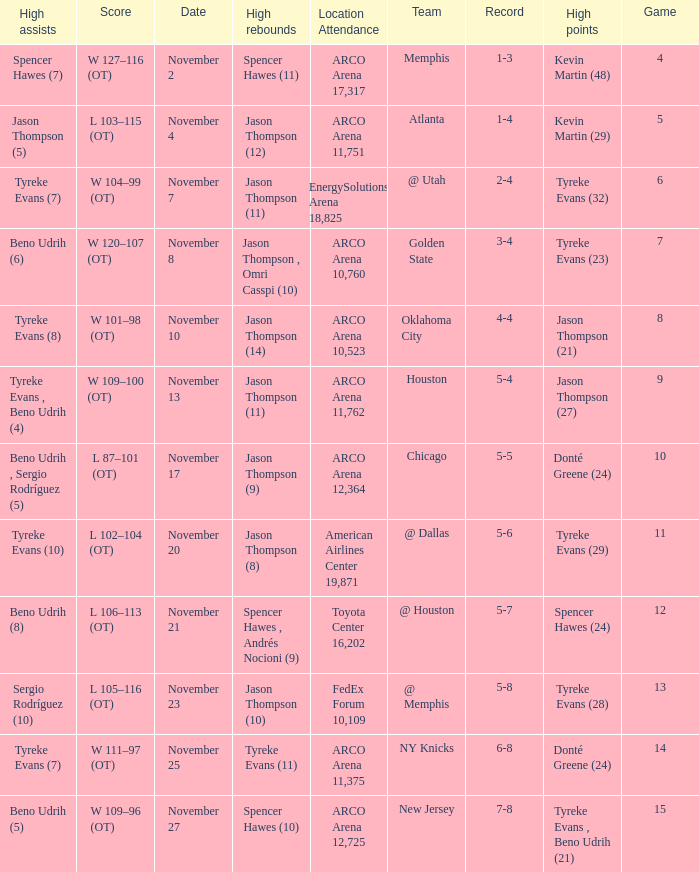If the record is 5-8, what is the team name? @ Memphis. 